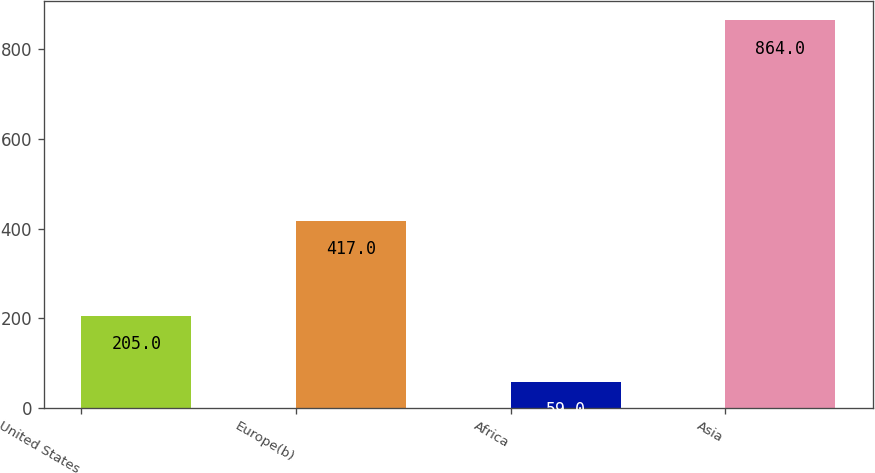Convert chart. <chart><loc_0><loc_0><loc_500><loc_500><bar_chart><fcel>United States<fcel>Europe(b)<fcel>Africa<fcel>Asia<nl><fcel>205<fcel>417<fcel>59<fcel>864<nl></chart> 